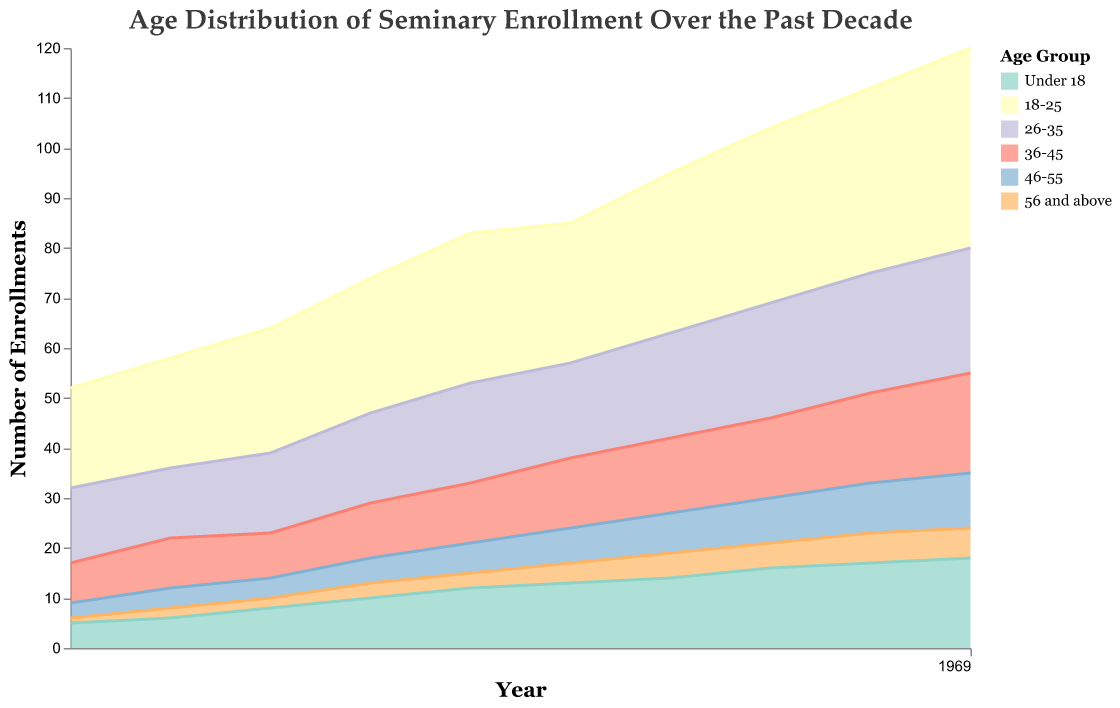How many age groups are represented in the chart? The chart legend lists the age groups. Each colored section corresponds to a specific age group. Counting them yields six age groups.
Answer: Six What is the title of the figure? The title is displayed at the top of the figure. It reads "Age Distribution of Seminary Enrollment Over the Past Decade."
Answer: Age Distribution of Seminary Enrollment Over the Past Decade Which age group saw the greatest increase in enrollments from 2013 to 2022? To determine the greatest increase, we subtract the 2013 values of each age group from their respective 2022 values. The age group 18-25 increased from 20 to 40, which is an increase of 20 enrollments, the largest among all groups.
Answer: 18-25 Considering the year 2016, which age group had the least number of enrollments and how many? From the numerical data for 2016, we see: Under 18 (10), 18-25 (27), 26-35 (18), 36-45 (11), 46-55 (5), 56 and above (3). The least enrollment was in the group "56 and above," with 3 enrollments.
Answer: 56 and above, 3 What's the trend in enrollments for the age group "Under 18" over the decade? The age group "Under 18" shows an increasing trend. Enrollments rise each year from 5 in 2013 to 18 in 2022.
Answer: Increasing Compare the enrollment numbers of the age groups "26-35" and "36-45" in 2017 and state the difference. In 2017, "26-35" had 20 enrollments and "36-45" had 12 enrollments. The difference is 20 - 12 = 8.
Answer: 8 Which age group had the highest number of enrollments in 2022? Checking the data for 2022, the age group "18-25" had the highest enrollment number, with 40 enrollees.
Answer: 18-25 By how much did the enrollments for the age group "46-55" increase from 2013 to 2019? In 2013, the age group "46-55" had 3 enrollments and in 2019, it had 8 enrollments. The increase is 8 - 3 = 5.
Answer: 5 What is the sum of enrollments for the age groups "18-25" and "26-35" in 2020? For 2020, "18-25" had 35 enrollments and "26-35" had 23 enrollments. Summing them yields 35 + 23 = 58.
Answer: 58 Which year had the smallest total number of enrollments? Summing enrollments for all the age groups across each year, we see that 2013 has the smallest total number of enrollments, with 52 in total.
Answer: 2013 